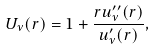Convert formula to latex. <formula><loc_0><loc_0><loc_500><loc_500>U _ { \nu } ( r ) = 1 + \frac { r u _ { \nu } ^ { \prime \prime } ( r ) } { u _ { \nu } ^ { \prime } ( r ) } ,</formula> 